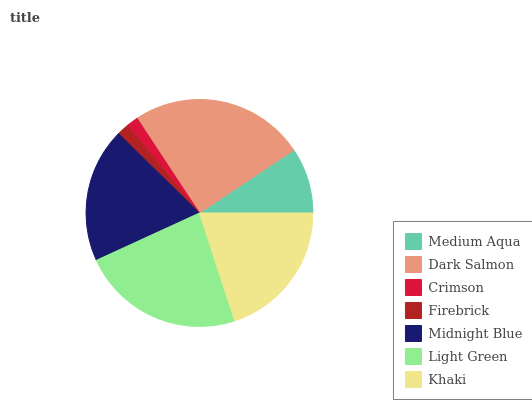Is Crimson the minimum?
Answer yes or no. Yes. Is Dark Salmon the maximum?
Answer yes or no. Yes. Is Dark Salmon the minimum?
Answer yes or no. No. Is Crimson the maximum?
Answer yes or no. No. Is Dark Salmon greater than Crimson?
Answer yes or no. Yes. Is Crimson less than Dark Salmon?
Answer yes or no. Yes. Is Crimson greater than Dark Salmon?
Answer yes or no. No. Is Dark Salmon less than Crimson?
Answer yes or no. No. Is Midnight Blue the high median?
Answer yes or no. Yes. Is Midnight Blue the low median?
Answer yes or no. Yes. Is Light Green the high median?
Answer yes or no. No. Is Firebrick the low median?
Answer yes or no. No. 